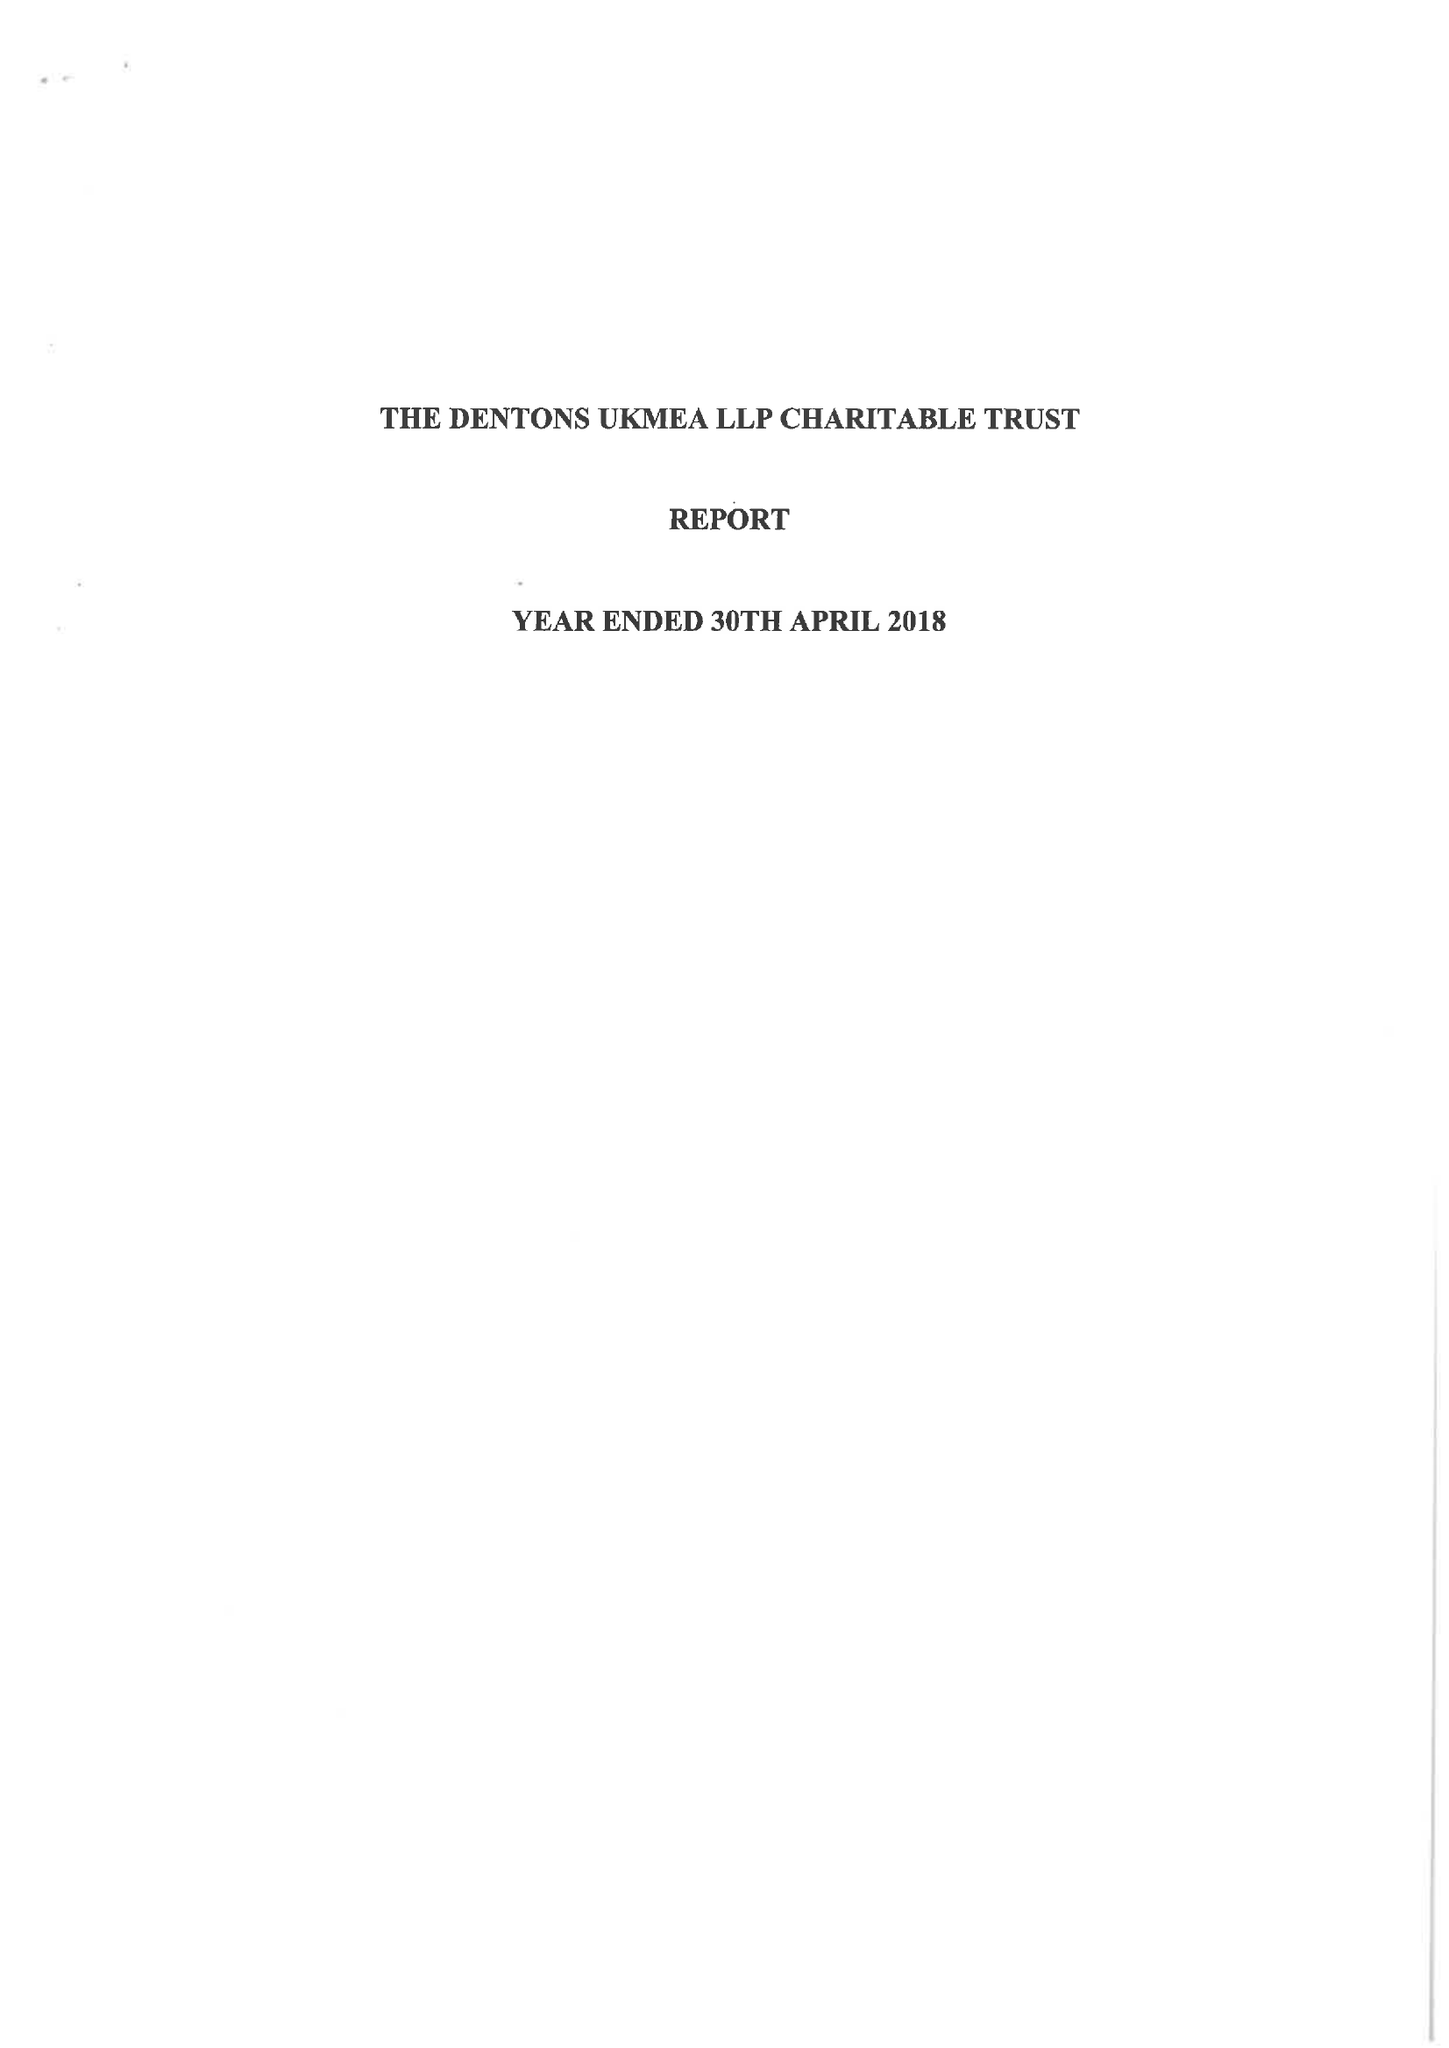What is the value for the spending_annually_in_british_pounds?
Answer the question using a single word or phrase. 130931.00 